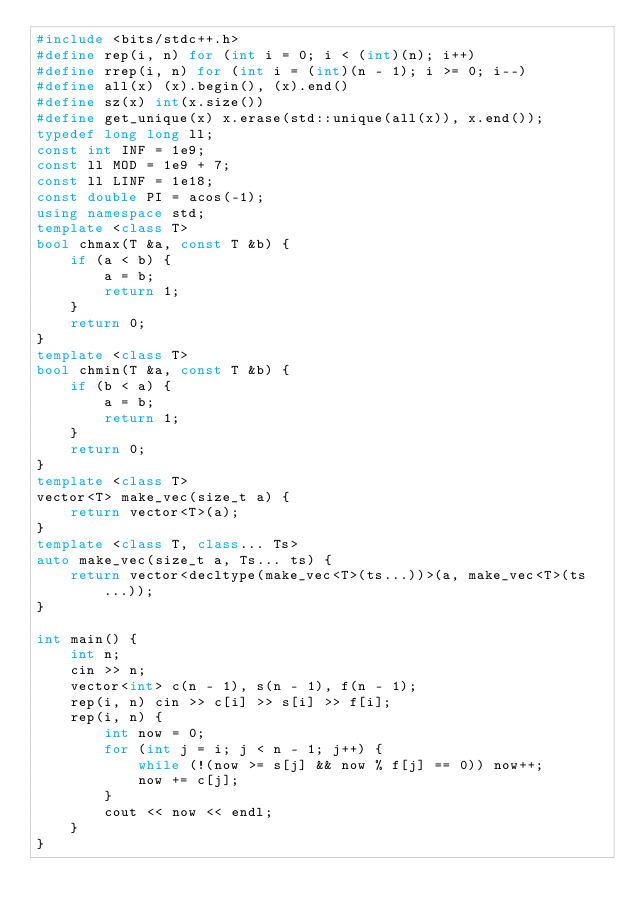Convert code to text. <code><loc_0><loc_0><loc_500><loc_500><_C++_>#include <bits/stdc++.h>
#define rep(i, n) for (int i = 0; i < (int)(n); i++)
#define rrep(i, n) for (int i = (int)(n - 1); i >= 0; i--)
#define all(x) (x).begin(), (x).end()
#define sz(x) int(x.size())
#define get_unique(x) x.erase(std::unique(all(x)), x.end());
typedef long long ll;
const int INF = 1e9;
const ll MOD = 1e9 + 7;
const ll LINF = 1e18;
const double PI = acos(-1);
using namespace std;
template <class T>
bool chmax(T &a, const T &b) {
    if (a < b) {
        a = b;
        return 1;
    }
    return 0;
}
template <class T>
bool chmin(T &a, const T &b) {
    if (b < a) {
        a = b;
        return 1;
    }
    return 0;
}
template <class T>
vector<T> make_vec(size_t a) {
    return vector<T>(a);
}
template <class T, class... Ts>
auto make_vec(size_t a, Ts... ts) {
    return vector<decltype(make_vec<T>(ts...))>(a, make_vec<T>(ts...));
}

int main() {
    int n;
    cin >> n;
    vector<int> c(n - 1), s(n - 1), f(n - 1);
    rep(i, n) cin >> c[i] >> s[i] >> f[i];
    rep(i, n) {
        int now = 0;
        for (int j = i; j < n - 1; j++) {
            while (!(now >= s[j] && now % f[j] == 0)) now++;
            now += c[j];
        }
        cout << now << endl;
    }
}
</code> 